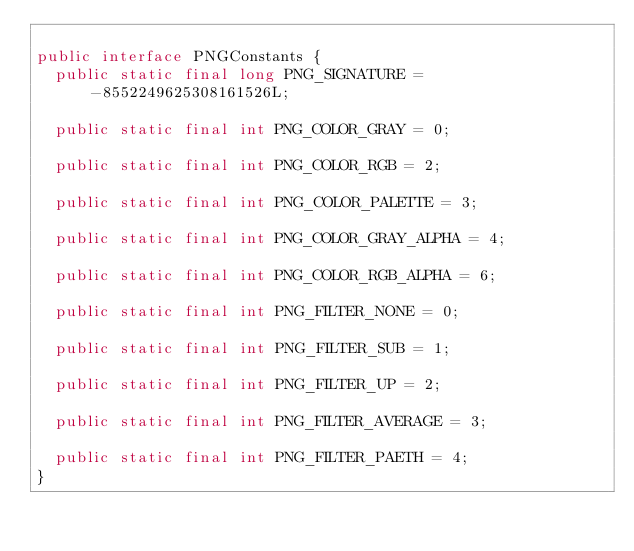Convert code to text. <code><loc_0><loc_0><loc_500><loc_500><_Java_>
public interface PNGConstants {
  public static final long PNG_SIGNATURE = -8552249625308161526L;
  
  public static final int PNG_COLOR_GRAY = 0;
  
  public static final int PNG_COLOR_RGB = 2;
  
  public static final int PNG_COLOR_PALETTE = 3;
  
  public static final int PNG_COLOR_GRAY_ALPHA = 4;
  
  public static final int PNG_COLOR_RGB_ALPHA = 6;
  
  public static final int PNG_FILTER_NONE = 0;
  
  public static final int PNG_FILTER_SUB = 1;
  
  public static final int PNG_FILTER_UP = 2;
  
  public static final int PNG_FILTER_AVERAGE = 3;
  
  public static final int PNG_FILTER_PAETH = 4;
}

</code> 